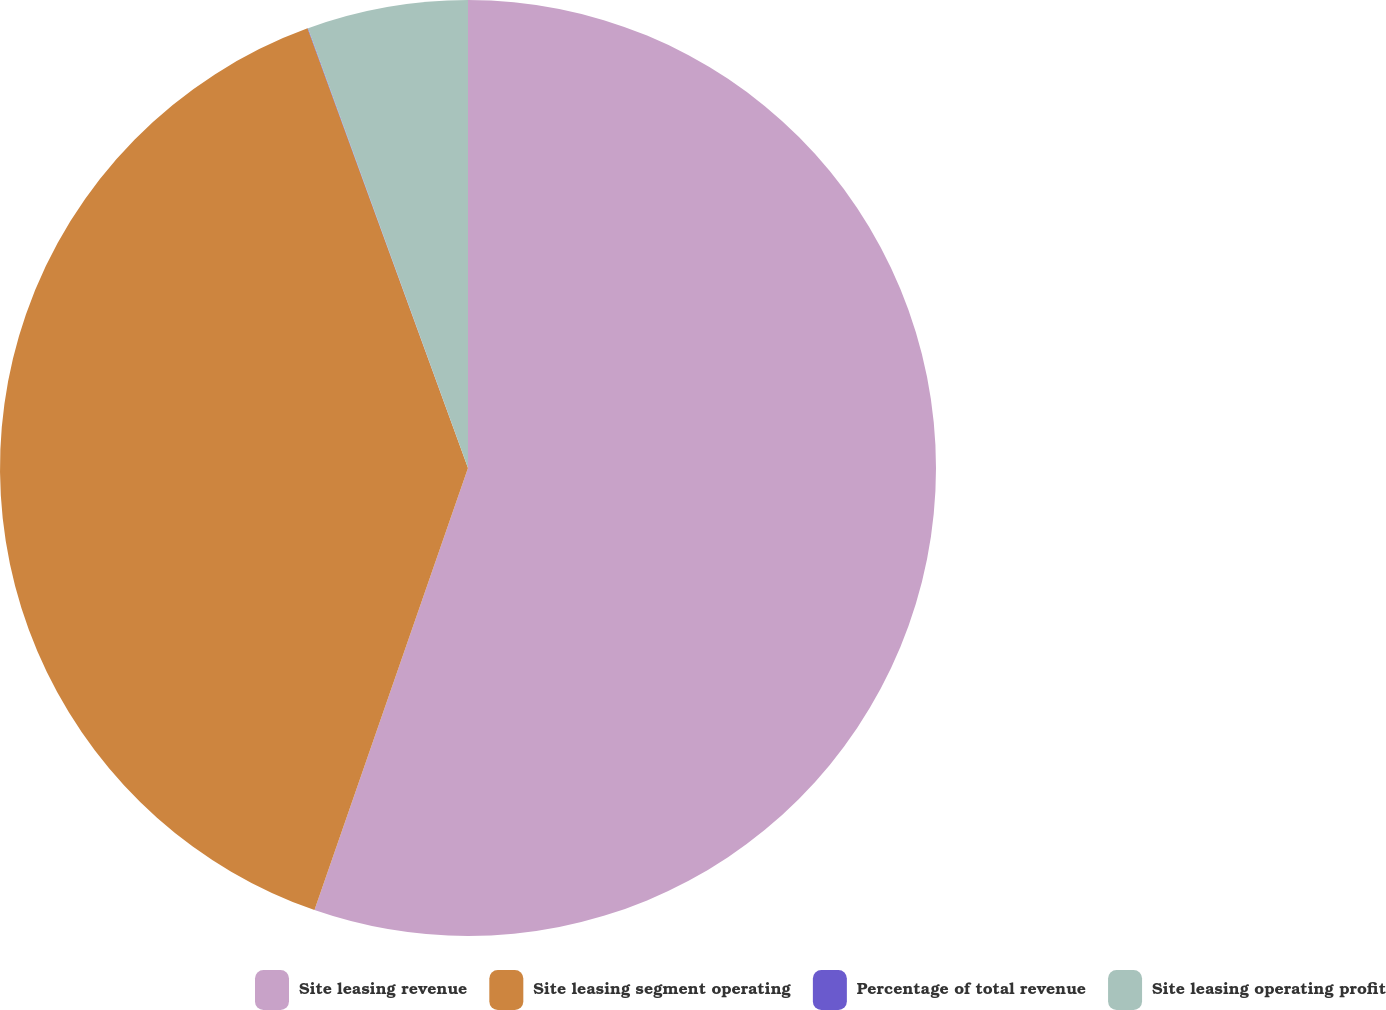<chart> <loc_0><loc_0><loc_500><loc_500><pie_chart><fcel>Site leasing revenue<fcel>Site leasing segment operating<fcel>Percentage of total revenue<fcel>Site leasing operating profit<nl><fcel>55.32%<fcel>39.11%<fcel>0.02%<fcel>5.55%<nl></chart> 